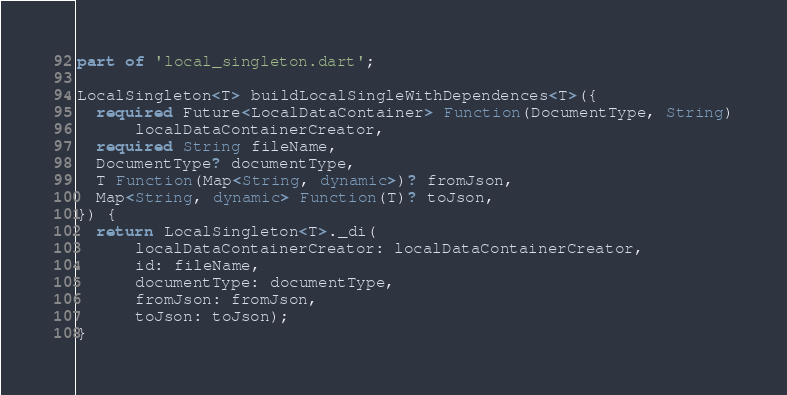<code> <loc_0><loc_0><loc_500><loc_500><_Dart_>part of 'local_singleton.dart';

LocalSingleton<T> buildLocalSingleWithDependences<T>({
  required Future<LocalDataContainer> Function(DocumentType, String)
      localDataContainerCreator,
  required String fileName,
  DocumentType? documentType,
  T Function(Map<String, dynamic>)? fromJson,
  Map<String, dynamic> Function(T)? toJson,
}) {
  return LocalSingleton<T>._di(
      localDataContainerCreator: localDataContainerCreator,
      id: fileName,
      documentType: documentType,
      fromJson: fromJson,
      toJson: toJson);
}
</code> 